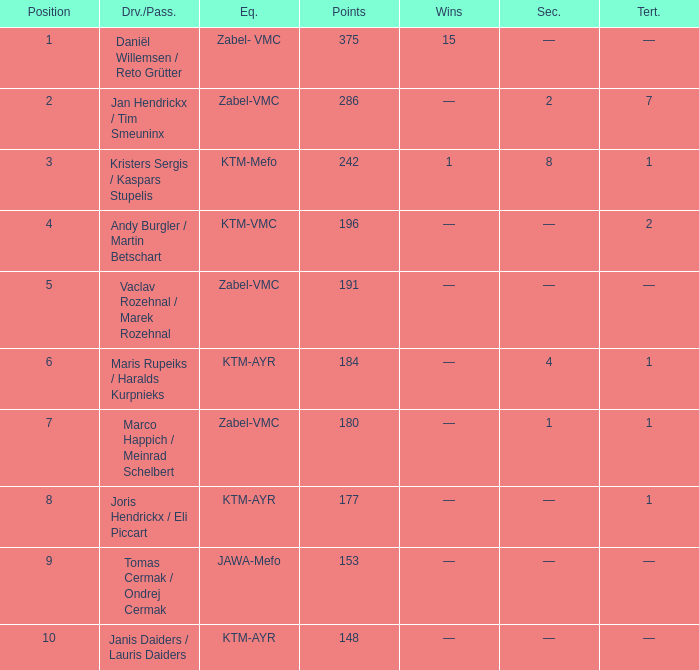What was the highest points when the second was 4? 184.0. 